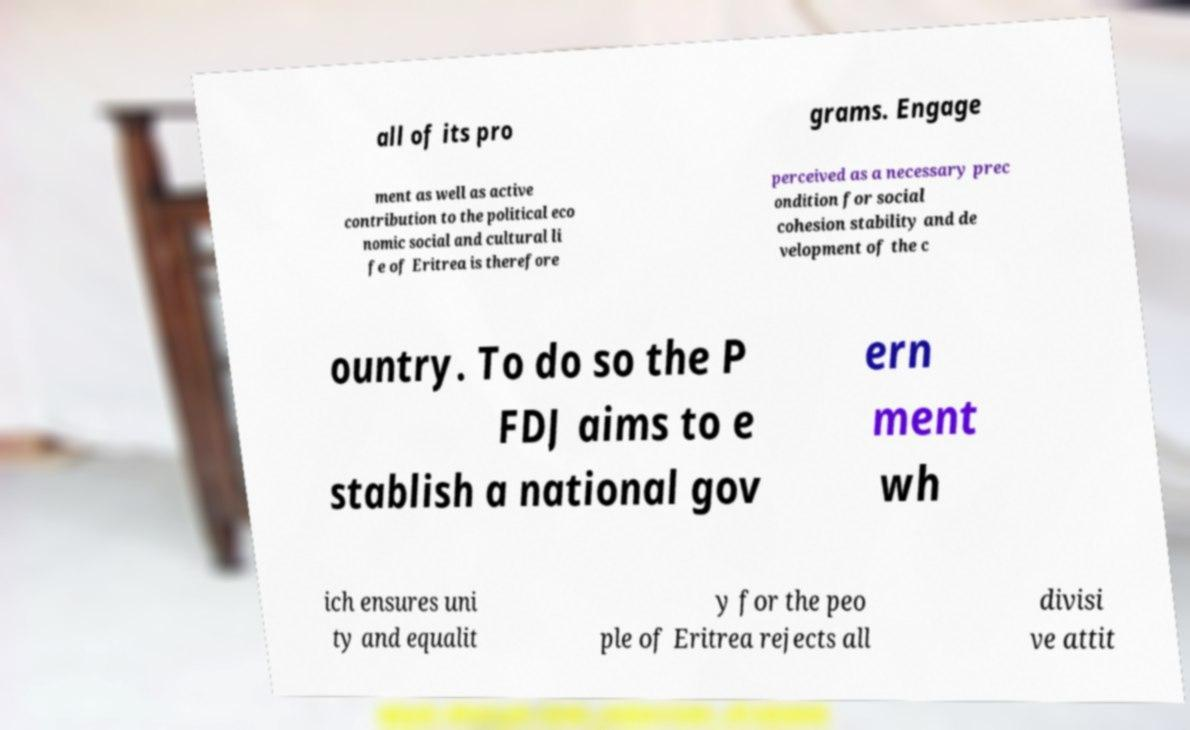Could you assist in decoding the text presented in this image and type it out clearly? all of its pro grams. Engage ment as well as active contribution to the political eco nomic social and cultural li fe of Eritrea is therefore perceived as a necessary prec ondition for social cohesion stability and de velopment of the c ountry. To do so the P FDJ aims to e stablish a national gov ern ment wh ich ensures uni ty and equalit y for the peo ple of Eritrea rejects all divisi ve attit 